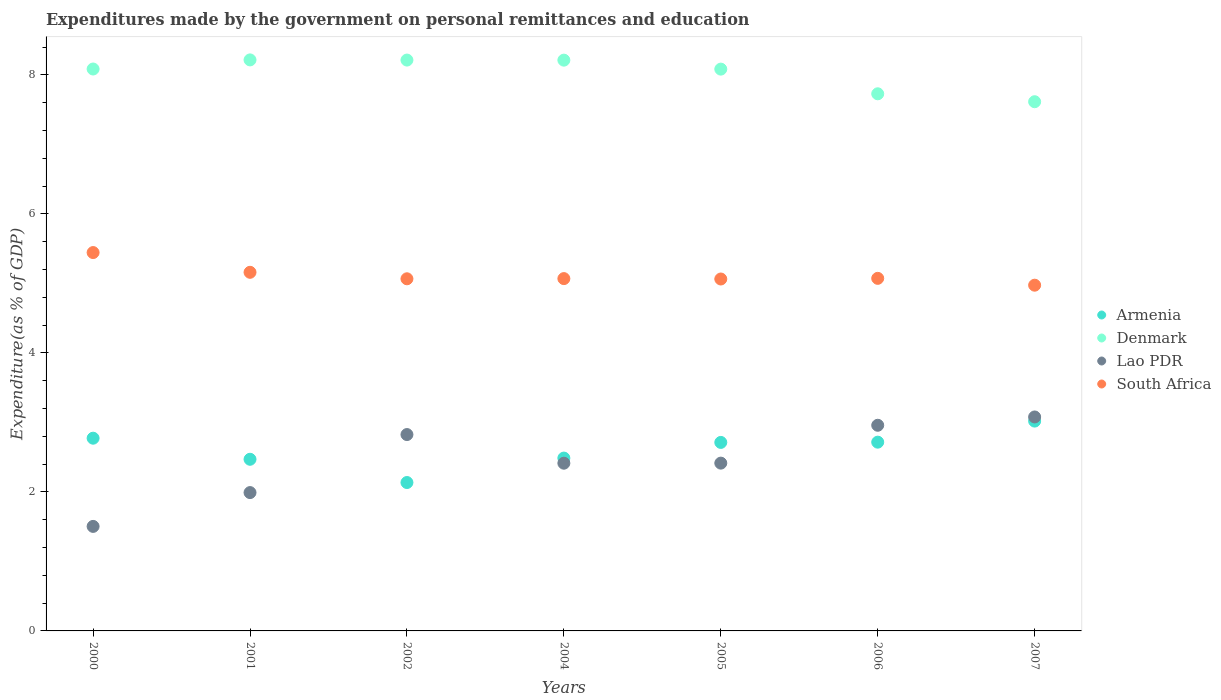How many different coloured dotlines are there?
Keep it short and to the point. 4. What is the expenditures made by the government on personal remittances and education in South Africa in 2007?
Your response must be concise. 4.97. Across all years, what is the maximum expenditures made by the government on personal remittances and education in Lao PDR?
Keep it short and to the point. 3.08. Across all years, what is the minimum expenditures made by the government on personal remittances and education in South Africa?
Your response must be concise. 4.97. In which year was the expenditures made by the government on personal remittances and education in Lao PDR maximum?
Offer a terse response. 2007. In which year was the expenditures made by the government on personal remittances and education in Denmark minimum?
Ensure brevity in your answer.  2007. What is the total expenditures made by the government on personal remittances and education in Denmark in the graph?
Offer a terse response. 56.15. What is the difference between the expenditures made by the government on personal remittances and education in Armenia in 2001 and that in 2004?
Keep it short and to the point. -0.02. What is the difference between the expenditures made by the government on personal remittances and education in Lao PDR in 2006 and the expenditures made by the government on personal remittances and education in Denmark in 2004?
Provide a short and direct response. -5.25. What is the average expenditures made by the government on personal remittances and education in Lao PDR per year?
Give a very brief answer. 2.45. In the year 2005, what is the difference between the expenditures made by the government on personal remittances and education in South Africa and expenditures made by the government on personal remittances and education in Denmark?
Offer a very short reply. -3.02. In how many years, is the expenditures made by the government on personal remittances and education in Lao PDR greater than 0.8 %?
Your answer should be compact. 7. What is the ratio of the expenditures made by the government on personal remittances and education in Denmark in 2001 to that in 2002?
Offer a terse response. 1. Is the expenditures made by the government on personal remittances and education in Armenia in 2005 less than that in 2006?
Make the answer very short. Yes. What is the difference between the highest and the second highest expenditures made by the government on personal remittances and education in Lao PDR?
Offer a very short reply. 0.12. What is the difference between the highest and the lowest expenditures made by the government on personal remittances and education in Denmark?
Your answer should be very brief. 0.6. In how many years, is the expenditures made by the government on personal remittances and education in Denmark greater than the average expenditures made by the government on personal remittances and education in Denmark taken over all years?
Provide a succinct answer. 5. Is it the case that in every year, the sum of the expenditures made by the government on personal remittances and education in Denmark and expenditures made by the government on personal remittances and education in Armenia  is greater than the expenditures made by the government on personal remittances and education in South Africa?
Ensure brevity in your answer.  Yes. Does the expenditures made by the government on personal remittances and education in Lao PDR monotonically increase over the years?
Your response must be concise. No. Is the expenditures made by the government on personal remittances and education in Armenia strictly less than the expenditures made by the government on personal remittances and education in Lao PDR over the years?
Your answer should be very brief. No. How many years are there in the graph?
Keep it short and to the point. 7. What is the difference between two consecutive major ticks on the Y-axis?
Ensure brevity in your answer.  2. How many legend labels are there?
Provide a succinct answer. 4. What is the title of the graph?
Provide a short and direct response. Expenditures made by the government on personal remittances and education. Does "St. Martin (French part)" appear as one of the legend labels in the graph?
Provide a succinct answer. No. What is the label or title of the X-axis?
Offer a terse response. Years. What is the label or title of the Y-axis?
Provide a succinct answer. Expenditure(as % of GDP). What is the Expenditure(as % of GDP) of Armenia in 2000?
Ensure brevity in your answer.  2.77. What is the Expenditure(as % of GDP) of Denmark in 2000?
Keep it short and to the point. 8.08. What is the Expenditure(as % of GDP) in Lao PDR in 2000?
Your response must be concise. 1.5. What is the Expenditure(as % of GDP) in South Africa in 2000?
Make the answer very short. 5.44. What is the Expenditure(as % of GDP) of Armenia in 2001?
Your answer should be compact. 2.47. What is the Expenditure(as % of GDP) in Denmark in 2001?
Your answer should be very brief. 8.22. What is the Expenditure(as % of GDP) of Lao PDR in 2001?
Keep it short and to the point. 1.99. What is the Expenditure(as % of GDP) in South Africa in 2001?
Your answer should be very brief. 5.16. What is the Expenditure(as % of GDP) in Armenia in 2002?
Ensure brevity in your answer.  2.14. What is the Expenditure(as % of GDP) of Denmark in 2002?
Provide a succinct answer. 8.21. What is the Expenditure(as % of GDP) in Lao PDR in 2002?
Offer a very short reply. 2.83. What is the Expenditure(as % of GDP) of South Africa in 2002?
Make the answer very short. 5.07. What is the Expenditure(as % of GDP) in Armenia in 2004?
Ensure brevity in your answer.  2.49. What is the Expenditure(as % of GDP) in Denmark in 2004?
Make the answer very short. 8.21. What is the Expenditure(as % of GDP) in Lao PDR in 2004?
Your response must be concise. 2.41. What is the Expenditure(as % of GDP) in South Africa in 2004?
Make the answer very short. 5.07. What is the Expenditure(as % of GDP) of Armenia in 2005?
Your answer should be compact. 2.71. What is the Expenditure(as % of GDP) of Denmark in 2005?
Offer a terse response. 8.08. What is the Expenditure(as % of GDP) of Lao PDR in 2005?
Your answer should be compact. 2.41. What is the Expenditure(as % of GDP) in South Africa in 2005?
Give a very brief answer. 5.06. What is the Expenditure(as % of GDP) of Armenia in 2006?
Keep it short and to the point. 2.72. What is the Expenditure(as % of GDP) of Denmark in 2006?
Your answer should be very brief. 7.73. What is the Expenditure(as % of GDP) of Lao PDR in 2006?
Your answer should be compact. 2.96. What is the Expenditure(as % of GDP) in South Africa in 2006?
Your response must be concise. 5.07. What is the Expenditure(as % of GDP) of Armenia in 2007?
Make the answer very short. 3.02. What is the Expenditure(as % of GDP) in Denmark in 2007?
Provide a short and direct response. 7.61. What is the Expenditure(as % of GDP) in Lao PDR in 2007?
Provide a succinct answer. 3.08. What is the Expenditure(as % of GDP) in South Africa in 2007?
Your response must be concise. 4.97. Across all years, what is the maximum Expenditure(as % of GDP) of Armenia?
Ensure brevity in your answer.  3.02. Across all years, what is the maximum Expenditure(as % of GDP) of Denmark?
Keep it short and to the point. 8.22. Across all years, what is the maximum Expenditure(as % of GDP) of Lao PDR?
Give a very brief answer. 3.08. Across all years, what is the maximum Expenditure(as % of GDP) in South Africa?
Your answer should be compact. 5.44. Across all years, what is the minimum Expenditure(as % of GDP) of Armenia?
Your answer should be compact. 2.14. Across all years, what is the minimum Expenditure(as % of GDP) in Denmark?
Make the answer very short. 7.61. Across all years, what is the minimum Expenditure(as % of GDP) of Lao PDR?
Give a very brief answer. 1.5. Across all years, what is the minimum Expenditure(as % of GDP) in South Africa?
Your response must be concise. 4.97. What is the total Expenditure(as % of GDP) of Armenia in the graph?
Your answer should be compact. 18.31. What is the total Expenditure(as % of GDP) in Denmark in the graph?
Ensure brevity in your answer.  56.15. What is the total Expenditure(as % of GDP) in Lao PDR in the graph?
Provide a succinct answer. 17.18. What is the total Expenditure(as % of GDP) in South Africa in the graph?
Your answer should be very brief. 35.85. What is the difference between the Expenditure(as % of GDP) in Armenia in 2000 and that in 2001?
Provide a succinct answer. 0.3. What is the difference between the Expenditure(as % of GDP) of Denmark in 2000 and that in 2001?
Provide a succinct answer. -0.13. What is the difference between the Expenditure(as % of GDP) of Lao PDR in 2000 and that in 2001?
Make the answer very short. -0.49. What is the difference between the Expenditure(as % of GDP) of South Africa in 2000 and that in 2001?
Keep it short and to the point. 0.28. What is the difference between the Expenditure(as % of GDP) of Armenia in 2000 and that in 2002?
Your answer should be very brief. 0.64. What is the difference between the Expenditure(as % of GDP) of Denmark in 2000 and that in 2002?
Provide a short and direct response. -0.13. What is the difference between the Expenditure(as % of GDP) of Lao PDR in 2000 and that in 2002?
Give a very brief answer. -1.32. What is the difference between the Expenditure(as % of GDP) in South Africa in 2000 and that in 2002?
Offer a very short reply. 0.38. What is the difference between the Expenditure(as % of GDP) in Armenia in 2000 and that in 2004?
Keep it short and to the point. 0.29. What is the difference between the Expenditure(as % of GDP) of Denmark in 2000 and that in 2004?
Keep it short and to the point. -0.13. What is the difference between the Expenditure(as % of GDP) in Lao PDR in 2000 and that in 2004?
Make the answer very short. -0.91. What is the difference between the Expenditure(as % of GDP) in South Africa in 2000 and that in 2004?
Offer a very short reply. 0.37. What is the difference between the Expenditure(as % of GDP) in Armenia in 2000 and that in 2005?
Give a very brief answer. 0.06. What is the difference between the Expenditure(as % of GDP) in Denmark in 2000 and that in 2005?
Give a very brief answer. 0. What is the difference between the Expenditure(as % of GDP) in Lao PDR in 2000 and that in 2005?
Provide a succinct answer. -0.91. What is the difference between the Expenditure(as % of GDP) of South Africa in 2000 and that in 2005?
Give a very brief answer. 0.38. What is the difference between the Expenditure(as % of GDP) of Armenia in 2000 and that in 2006?
Make the answer very short. 0.06. What is the difference between the Expenditure(as % of GDP) in Denmark in 2000 and that in 2006?
Your answer should be very brief. 0.36. What is the difference between the Expenditure(as % of GDP) of Lao PDR in 2000 and that in 2006?
Offer a terse response. -1.46. What is the difference between the Expenditure(as % of GDP) of South Africa in 2000 and that in 2006?
Make the answer very short. 0.37. What is the difference between the Expenditure(as % of GDP) in Armenia in 2000 and that in 2007?
Provide a succinct answer. -0.25. What is the difference between the Expenditure(as % of GDP) of Denmark in 2000 and that in 2007?
Provide a short and direct response. 0.47. What is the difference between the Expenditure(as % of GDP) in Lao PDR in 2000 and that in 2007?
Your response must be concise. -1.57. What is the difference between the Expenditure(as % of GDP) of South Africa in 2000 and that in 2007?
Offer a terse response. 0.47. What is the difference between the Expenditure(as % of GDP) in Armenia in 2001 and that in 2002?
Make the answer very short. 0.33. What is the difference between the Expenditure(as % of GDP) of Denmark in 2001 and that in 2002?
Provide a short and direct response. 0. What is the difference between the Expenditure(as % of GDP) of Lao PDR in 2001 and that in 2002?
Keep it short and to the point. -0.83. What is the difference between the Expenditure(as % of GDP) in South Africa in 2001 and that in 2002?
Your answer should be compact. 0.09. What is the difference between the Expenditure(as % of GDP) of Armenia in 2001 and that in 2004?
Offer a terse response. -0.02. What is the difference between the Expenditure(as % of GDP) in Denmark in 2001 and that in 2004?
Give a very brief answer. 0. What is the difference between the Expenditure(as % of GDP) in Lao PDR in 2001 and that in 2004?
Your answer should be very brief. -0.42. What is the difference between the Expenditure(as % of GDP) of South Africa in 2001 and that in 2004?
Make the answer very short. 0.09. What is the difference between the Expenditure(as % of GDP) in Armenia in 2001 and that in 2005?
Keep it short and to the point. -0.24. What is the difference between the Expenditure(as % of GDP) in Denmark in 2001 and that in 2005?
Offer a terse response. 0.13. What is the difference between the Expenditure(as % of GDP) in Lao PDR in 2001 and that in 2005?
Offer a very short reply. -0.42. What is the difference between the Expenditure(as % of GDP) in South Africa in 2001 and that in 2005?
Your response must be concise. 0.1. What is the difference between the Expenditure(as % of GDP) in Armenia in 2001 and that in 2006?
Your answer should be compact. -0.25. What is the difference between the Expenditure(as % of GDP) in Denmark in 2001 and that in 2006?
Offer a terse response. 0.49. What is the difference between the Expenditure(as % of GDP) in Lao PDR in 2001 and that in 2006?
Give a very brief answer. -0.97. What is the difference between the Expenditure(as % of GDP) of South Africa in 2001 and that in 2006?
Make the answer very short. 0.09. What is the difference between the Expenditure(as % of GDP) of Armenia in 2001 and that in 2007?
Your answer should be very brief. -0.55. What is the difference between the Expenditure(as % of GDP) in Denmark in 2001 and that in 2007?
Keep it short and to the point. 0.6. What is the difference between the Expenditure(as % of GDP) in Lao PDR in 2001 and that in 2007?
Provide a short and direct response. -1.09. What is the difference between the Expenditure(as % of GDP) in South Africa in 2001 and that in 2007?
Your answer should be compact. 0.19. What is the difference between the Expenditure(as % of GDP) in Armenia in 2002 and that in 2004?
Offer a very short reply. -0.35. What is the difference between the Expenditure(as % of GDP) of Denmark in 2002 and that in 2004?
Your answer should be very brief. 0. What is the difference between the Expenditure(as % of GDP) of Lao PDR in 2002 and that in 2004?
Ensure brevity in your answer.  0.41. What is the difference between the Expenditure(as % of GDP) of South Africa in 2002 and that in 2004?
Provide a short and direct response. -0. What is the difference between the Expenditure(as % of GDP) in Armenia in 2002 and that in 2005?
Your response must be concise. -0.58. What is the difference between the Expenditure(as % of GDP) in Denmark in 2002 and that in 2005?
Your response must be concise. 0.13. What is the difference between the Expenditure(as % of GDP) in Lao PDR in 2002 and that in 2005?
Keep it short and to the point. 0.41. What is the difference between the Expenditure(as % of GDP) of South Africa in 2002 and that in 2005?
Offer a terse response. 0. What is the difference between the Expenditure(as % of GDP) in Armenia in 2002 and that in 2006?
Your answer should be compact. -0.58. What is the difference between the Expenditure(as % of GDP) in Denmark in 2002 and that in 2006?
Offer a very short reply. 0.49. What is the difference between the Expenditure(as % of GDP) of Lao PDR in 2002 and that in 2006?
Offer a terse response. -0.13. What is the difference between the Expenditure(as % of GDP) of South Africa in 2002 and that in 2006?
Your response must be concise. -0.01. What is the difference between the Expenditure(as % of GDP) in Armenia in 2002 and that in 2007?
Ensure brevity in your answer.  -0.88. What is the difference between the Expenditure(as % of GDP) in Denmark in 2002 and that in 2007?
Give a very brief answer. 0.6. What is the difference between the Expenditure(as % of GDP) of Lao PDR in 2002 and that in 2007?
Make the answer very short. -0.25. What is the difference between the Expenditure(as % of GDP) in South Africa in 2002 and that in 2007?
Ensure brevity in your answer.  0.09. What is the difference between the Expenditure(as % of GDP) in Armenia in 2004 and that in 2005?
Provide a short and direct response. -0.23. What is the difference between the Expenditure(as % of GDP) of Denmark in 2004 and that in 2005?
Keep it short and to the point. 0.13. What is the difference between the Expenditure(as % of GDP) of Lao PDR in 2004 and that in 2005?
Your answer should be very brief. -0. What is the difference between the Expenditure(as % of GDP) of South Africa in 2004 and that in 2005?
Keep it short and to the point. 0.01. What is the difference between the Expenditure(as % of GDP) in Armenia in 2004 and that in 2006?
Provide a succinct answer. -0.23. What is the difference between the Expenditure(as % of GDP) of Denmark in 2004 and that in 2006?
Give a very brief answer. 0.48. What is the difference between the Expenditure(as % of GDP) of Lao PDR in 2004 and that in 2006?
Keep it short and to the point. -0.55. What is the difference between the Expenditure(as % of GDP) of South Africa in 2004 and that in 2006?
Give a very brief answer. -0. What is the difference between the Expenditure(as % of GDP) in Armenia in 2004 and that in 2007?
Offer a very short reply. -0.53. What is the difference between the Expenditure(as % of GDP) of Denmark in 2004 and that in 2007?
Make the answer very short. 0.6. What is the difference between the Expenditure(as % of GDP) in Lao PDR in 2004 and that in 2007?
Make the answer very short. -0.67. What is the difference between the Expenditure(as % of GDP) of South Africa in 2004 and that in 2007?
Make the answer very short. 0.09. What is the difference between the Expenditure(as % of GDP) in Armenia in 2005 and that in 2006?
Keep it short and to the point. -0. What is the difference between the Expenditure(as % of GDP) in Denmark in 2005 and that in 2006?
Make the answer very short. 0.35. What is the difference between the Expenditure(as % of GDP) of Lao PDR in 2005 and that in 2006?
Keep it short and to the point. -0.54. What is the difference between the Expenditure(as % of GDP) in South Africa in 2005 and that in 2006?
Your answer should be very brief. -0.01. What is the difference between the Expenditure(as % of GDP) of Armenia in 2005 and that in 2007?
Your response must be concise. -0.31. What is the difference between the Expenditure(as % of GDP) in Denmark in 2005 and that in 2007?
Provide a short and direct response. 0.47. What is the difference between the Expenditure(as % of GDP) of Lao PDR in 2005 and that in 2007?
Your answer should be compact. -0.66. What is the difference between the Expenditure(as % of GDP) of South Africa in 2005 and that in 2007?
Give a very brief answer. 0.09. What is the difference between the Expenditure(as % of GDP) of Armenia in 2006 and that in 2007?
Give a very brief answer. -0.3. What is the difference between the Expenditure(as % of GDP) of Denmark in 2006 and that in 2007?
Your answer should be very brief. 0.11. What is the difference between the Expenditure(as % of GDP) of Lao PDR in 2006 and that in 2007?
Keep it short and to the point. -0.12. What is the difference between the Expenditure(as % of GDP) in South Africa in 2006 and that in 2007?
Ensure brevity in your answer.  0.1. What is the difference between the Expenditure(as % of GDP) in Armenia in 2000 and the Expenditure(as % of GDP) in Denmark in 2001?
Provide a short and direct response. -5.44. What is the difference between the Expenditure(as % of GDP) in Armenia in 2000 and the Expenditure(as % of GDP) in Lao PDR in 2001?
Your answer should be compact. 0.78. What is the difference between the Expenditure(as % of GDP) in Armenia in 2000 and the Expenditure(as % of GDP) in South Africa in 2001?
Make the answer very short. -2.39. What is the difference between the Expenditure(as % of GDP) in Denmark in 2000 and the Expenditure(as % of GDP) in Lao PDR in 2001?
Your response must be concise. 6.09. What is the difference between the Expenditure(as % of GDP) of Denmark in 2000 and the Expenditure(as % of GDP) of South Africa in 2001?
Keep it short and to the point. 2.92. What is the difference between the Expenditure(as % of GDP) in Lao PDR in 2000 and the Expenditure(as % of GDP) in South Africa in 2001?
Your answer should be very brief. -3.66. What is the difference between the Expenditure(as % of GDP) of Armenia in 2000 and the Expenditure(as % of GDP) of Denmark in 2002?
Your response must be concise. -5.44. What is the difference between the Expenditure(as % of GDP) of Armenia in 2000 and the Expenditure(as % of GDP) of Lao PDR in 2002?
Your answer should be compact. -0.05. What is the difference between the Expenditure(as % of GDP) in Armenia in 2000 and the Expenditure(as % of GDP) in South Africa in 2002?
Keep it short and to the point. -2.29. What is the difference between the Expenditure(as % of GDP) of Denmark in 2000 and the Expenditure(as % of GDP) of Lao PDR in 2002?
Your answer should be very brief. 5.26. What is the difference between the Expenditure(as % of GDP) of Denmark in 2000 and the Expenditure(as % of GDP) of South Africa in 2002?
Provide a short and direct response. 3.02. What is the difference between the Expenditure(as % of GDP) of Lao PDR in 2000 and the Expenditure(as % of GDP) of South Africa in 2002?
Ensure brevity in your answer.  -3.56. What is the difference between the Expenditure(as % of GDP) of Armenia in 2000 and the Expenditure(as % of GDP) of Denmark in 2004?
Make the answer very short. -5.44. What is the difference between the Expenditure(as % of GDP) in Armenia in 2000 and the Expenditure(as % of GDP) in Lao PDR in 2004?
Provide a succinct answer. 0.36. What is the difference between the Expenditure(as % of GDP) of Armenia in 2000 and the Expenditure(as % of GDP) of South Africa in 2004?
Your answer should be compact. -2.3. What is the difference between the Expenditure(as % of GDP) in Denmark in 2000 and the Expenditure(as % of GDP) in Lao PDR in 2004?
Your answer should be very brief. 5.67. What is the difference between the Expenditure(as % of GDP) in Denmark in 2000 and the Expenditure(as % of GDP) in South Africa in 2004?
Make the answer very short. 3.02. What is the difference between the Expenditure(as % of GDP) in Lao PDR in 2000 and the Expenditure(as % of GDP) in South Africa in 2004?
Provide a succinct answer. -3.57. What is the difference between the Expenditure(as % of GDP) of Armenia in 2000 and the Expenditure(as % of GDP) of Denmark in 2005?
Keep it short and to the point. -5.31. What is the difference between the Expenditure(as % of GDP) of Armenia in 2000 and the Expenditure(as % of GDP) of Lao PDR in 2005?
Give a very brief answer. 0.36. What is the difference between the Expenditure(as % of GDP) of Armenia in 2000 and the Expenditure(as % of GDP) of South Africa in 2005?
Ensure brevity in your answer.  -2.29. What is the difference between the Expenditure(as % of GDP) in Denmark in 2000 and the Expenditure(as % of GDP) in Lao PDR in 2005?
Provide a short and direct response. 5.67. What is the difference between the Expenditure(as % of GDP) of Denmark in 2000 and the Expenditure(as % of GDP) of South Africa in 2005?
Your answer should be very brief. 3.02. What is the difference between the Expenditure(as % of GDP) of Lao PDR in 2000 and the Expenditure(as % of GDP) of South Africa in 2005?
Provide a succinct answer. -3.56. What is the difference between the Expenditure(as % of GDP) in Armenia in 2000 and the Expenditure(as % of GDP) in Denmark in 2006?
Give a very brief answer. -4.96. What is the difference between the Expenditure(as % of GDP) of Armenia in 2000 and the Expenditure(as % of GDP) of Lao PDR in 2006?
Provide a short and direct response. -0.19. What is the difference between the Expenditure(as % of GDP) in Armenia in 2000 and the Expenditure(as % of GDP) in South Africa in 2006?
Your answer should be very brief. -2.3. What is the difference between the Expenditure(as % of GDP) of Denmark in 2000 and the Expenditure(as % of GDP) of Lao PDR in 2006?
Offer a very short reply. 5.13. What is the difference between the Expenditure(as % of GDP) in Denmark in 2000 and the Expenditure(as % of GDP) in South Africa in 2006?
Ensure brevity in your answer.  3.01. What is the difference between the Expenditure(as % of GDP) in Lao PDR in 2000 and the Expenditure(as % of GDP) in South Africa in 2006?
Your answer should be very brief. -3.57. What is the difference between the Expenditure(as % of GDP) of Armenia in 2000 and the Expenditure(as % of GDP) of Denmark in 2007?
Your response must be concise. -4.84. What is the difference between the Expenditure(as % of GDP) of Armenia in 2000 and the Expenditure(as % of GDP) of Lao PDR in 2007?
Your answer should be very brief. -0.31. What is the difference between the Expenditure(as % of GDP) of Armenia in 2000 and the Expenditure(as % of GDP) of South Africa in 2007?
Make the answer very short. -2.2. What is the difference between the Expenditure(as % of GDP) in Denmark in 2000 and the Expenditure(as % of GDP) in Lao PDR in 2007?
Ensure brevity in your answer.  5.01. What is the difference between the Expenditure(as % of GDP) of Denmark in 2000 and the Expenditure(as % of GDP) of South Africa in 2007?
Ensure brevity in your answer.  3.11. What is the difference between the Expenditure(as % of GDP) in Lao PDR in 2000 and the Expenditure(as % of GDP) in South Africa in 2007?
Make the answer very short. -3.47. What is the difference between the Expenditure(as % of GDP) in Armenia in 2001 and the Expenditure(as % of GDP) in Denmark in 2002?
Give a very brief answer. -5.74. What is the difference between the Expenditure(as % of GDP) of Armenia in 2001 and the Expenditure(as % of GDP) of Lao PDR in 2002?
Keep it short and to the point. -0.36. What is the difference between the Expenditure(as % of GDP) in Armenia in 2001 and the Expenditure(as % of GDP) in South Africa in 2002?
Offer a terse response. -2.6. What is the difference between the Expenditure(as % of GDP) in Denmark in 2001 and the Expenditure(as % of GDP) in Lao PDR in 2002?
Give a very brief answer. 5.39. What is the difference between the Expenditure(as % of GDP) of Denmark in 2001 and the Expenditure(as % of GDP) of South Africa in 2002?
Offer a terse response. 3.15. What is the difference between the Expenditure(as % of GDP) of Lao PDR in 2001 and the Expenditure(as % of GDP) of South Africa in 2002?
Your response must be concise. -3.08. What is the difference between the Expenditure(as % of GDP) of Armenia in 2001 and the Expenditure(as % of GDP) of Denmark in 2004?
Offer a terse response. -5.74. What is the difference between the Expenditure(as % of GDP) in Armenia in 2001 and the Expenditure(as % of GDP) in Lao PDR in 2004?
Offer a very short reply. 0.06. What is the difference between the Expenditure(as % of GDP) of Armenia in 2001 and the Expenditure(as % of GDP) of South Africa in 2004?
Provide a short and direct response. -2.6. What is the difference between the Expenditure(as % of GDP) of Denmark in 2001 and the Expenditure(as % of GDP) of Lao PDR in 2004?
Your answer should be very brief. 5.8. What is the difference between the Expenditure(as % of GDP) of Denmark in 2001 and the Expenditure(as % of GDP) of South Africa in 2004?
Your response must be concise. 3.15. What is the difference between the Expenditure(as % of GDP) in Lao PDR in 2001 and the Expenditure(as % of GDP) in South Africa in 2004?
Keep it short and to the point. -3.08. What is the difference between the Expenditure(as % of GDP) in Armenia in 2001 and the Expenditure(as % of GDP) in Denmark in 2005?
Give a very brief answer. -5.61. What is the difference between the Expenditure(as % of GDP) of Armenia in 2001 and the Expenditure(as % of GDP) of Lao PDR in 2005?
Give a very brief answer. 0.06. What is the difference between the Expenditure(as % of GDP) in Armenia in 2001 and the Expenditure(as % of GDP) in South Africa in 2005?
Offer a terse response. -2.59. What is the difference between the Expenditure(as % of GDP) in Denmark in 2001 and the Expenditure(as % of GDP) in Lao PDR in 2005?
Offer a very short reply. 5.8. What is the difference between the Expenditure(as % of GDP) in Denmark in 2001 and the Expenditure(as % of GDP) in South Africa in 2005?
Provide a succinct answer. 3.15. What is the difference between the Expenditure(as % of GDP) in Lao PDR in 2001 and the Expenditure(as % of GDP) in South Africa in 2005?
Offer a very short reply. -3.07. What is the difference between the Expenditure(as % of GDP) of Armenia in 2001 and the Expenditure(as % of GDP) of Denmark in 2006?
Make the answer very short. -5.26. What is the difference between the Expenditure(as % of GDP) of Armenia in 2001 and the Expenditure(as % of GDP) of Lao PDR in 2006?
Give a very brief answer. -0.49. What is the difference between the Expenditure(as % of GDP) of Armenia in 2001 and the Expenditure(as % of GDP) of South Africa in 2006?
Provide a succinct answer. -2.6. What is the difference between the Expenditure(as % of GDP) in Denmark in 2001 and the Expenditure(as % of GDP) in Lao PDR in 2006?
Provide a succinct answer. 5.26. What is the difference between the Expenditure(as % of GDP) in Denmark in 2001 and the Expenditure(as % of GDP) in South Africa in 2006?
Your answer should be very brief. 3.14. What is the difference between the Expenditure(as % of GDP) in Lao PDR in 2001 and the Expenditure(as % of GDP) in South Africa in 2006?
Keep it short and to the point. -3.08. What is the difference between the Expenditure(as % of GDP) in Armenia in 2001 and the Expenditure(as % of GDP) in Denmark in 2007?
Your answer should be compact. -5.14. What is the difference between the Expenditure(as % of GDP) in Armenia in 2001 and the Expenditure(as % of GDP) in Lao PDR in 2007?
Keep it short and to the point. -0.61. What is the difference between the Expenditure(as % of GDP) in Armenia in 2001 and the Expenditure(as % of GDP) in South Africa in 2007?
Your answer should be compact. -2.5. What is the difference between the Expenditure(as % of GDP) of Denmark in 2001 and the Expenditure(as % of GDP) of Lao PDR in 2007?
Offer a terse response. 5.14. What is the difference between the Expenditure(as % of GDP) of Denmark in 2001 and the Expenditure(as % of GDP) of South Africa in 2007?
Your response must be concise. 3.24. What is the difference between the Expenditure(as % of GDP) in Lao PDR in 2001 and the Expenditure(as % of GDP) in South Africa in 2007?
Keep it short and to the point. -2.98. What is the difference between the Expenditure(as % of GDP) in Armenia in 2002 and the Expenditure(as % of GDP) in Denmark in 2004?
Offer a terse response. -6.08. What is the difference between the Expenditure(as % of GDP) in Armenia in 2002 and the Expenditure(as % of GDP) in Lao PDR in 2004?
Provide a succinct answer. -0.28. What is the difference between the Expenditure(as % of GDP) of Armenia in 2002 and the Expenditure(as % of GDP) of South Africa in 2004?
Make the answer very short. -2.93. What is the difference between the Expenditure(as % of GDP) of Denmark in 2002 and the Expenditure(as % of GDP) of South Africa in 2004?
Offer a very short reply. 3.14. What is the difference between the Expenditure(as % of GDP) in Lao PDR in 2002 and the Expenditure(as % of GDP) in South Africa in 2004?
Provide a short and direct response. -2.24. What is the difference between the Expenditure(as % of GDP) in Armenia in 2002 and the Expenditure(as % of GDP) in Denmark in 2005?
Make the answer very short. -5.95. What is the difference between the Expenditure(as % of GDP) of Armenia in 2002 and the Expenditure(as % of GDP) of Lao PDR in 2005?
Provide a short and direct response. -0.28. What is the difference between the Expenditure(as % of GDP) in Armenia in 2002 and the Expenditure(as % of GDP) in South Africa in 2005?
Make the answer very short. -2.93. What is the difference between the Expenditure(as % of GDP) in Denmark in 2002 and the Expenditure(as % of GDP) in Lao PDR in 2005?
Give a very brief answer. 5.8. What is the difference between the Expenditure(as % of GDP) of Denmark in 2002 and the Expenditure(as % of GDP) of South Africa in 2005?
Give a very brief answer. 3.15. What is the difference between the Expenditure(as % of GDP) of Lao PDR in 2002 and the Expenditure(as % of GDP) of South Africa in 2005?
Provide a succinct answer. -2.24. What is the difference between the Expenditure(as % of GDP) of Armenia in 2002 and the Expenditure(as % of GDP) of Denmark in 2006?
Offer a very short reply. -5.59. What is the difference between the Expenditure(as % of GDP) in Armenia in 2002 and the Expenditure(as % of GDP) in Lao PDR in 2006?
Ensure brevity in your answer.  -0.82. What is the difference between the Expenditure(as % of GDP) in Armenia in 2002 and the Expenditure(as % of GDP) in South Africa in 2006?
Offer a terse response. -2.94. What is the difference between the Expenditure(as % of GDP) of Denmark in 2002 and the Expenditure(as % of GDP) of Lao PDR in 2006?
Offer a terse response. 5.25. What is the difference between the Expenditure(as % of GDP) in Denmark in 2002 and the Expenditure(as % of GDP) in South Africa in 2006?
Your response must be concise. 3.14. What is the difference between the Expenditure(as % of GDP) in Lao PDR in 2002 and the Expenditure(as % of GDP) in South Africa in 2006?
Offer a terse response. -2.25. What is the difference between the Expenditure(as % of GDP) in Armenia in 2002 and the Expenditure(as % of GDP) in Denmark in 2007?
Make the answer very short. -5.48. What is the difference between the Expenditure(as % of GDP) of Armenia in 2002 and the Expenditure(as % of GDP) of Lao PDR in 2007?
Provide a short and direct response. -0.94. What is the difference between the Expenditure(as % of GDP) in Armenia in 2002 and the Expenditure(as % of GDP) in South Africa in 2007?
Provide a succinct answer. -2.84. What is the difference between the Expenditure(as % of GDP) of Denmark in 2002 and the Expenditure(as % of GDP) of Lao PDR in 2007?
Provide a short and direct response. 5.13. What is the difference between the Expenditure(as % of GDP) of Denmark in 2002 and the Expenditure(as % of GDP) of South Africa in 2007?
Ensure brevity in your answer.  3.24. What is the difference between the Expenditure(as % of GDP) of Lao PDR in 2002 and the Expenditure(as % of GDP) of South Africa in 2007?
Keep it short and to the point. -2.15. What is the difference between the Expenditure(as % of GDP) in Armenia in 2004 and the Expenditure(as % of GDP) in Denmark in 2005?
Give a very brief answer. -5.6. What is the difference between the Expenditure(as % of GDP) in Armenia in 2004 and the Expenditure(as % of GDP) in Lao PDR in 2005?
Offer a very short reply. 0.07. What is the difference between the Expenditure(as % of GDP) of Armenia in 2004 and the Expenditure(as % of GDP) of South Africa in 2005?
Your answer should be very brief. -2.58. What is the difference between the Expenditure(as % of GDP) in Denmark in 2004 and the Expenditure(as % of GDP) in Lao PDR in 2005?
Provide a succinct answer. 5.8. What is the difference between the Expenditure(as % of GDP) in Denmark in 2004 and the Expenditure(as % of GDP) in South Africa in 2005?
Your answer should be very brief. 3.15. What is the difference between the Expenditure(as % of GDP) of Lao PDR in 2004 and the Expenditure(as % of GDP) of South Africa in 2005?
Offer a terse response. -2.65. What is the difference between the Expenditure(as % of GDP) of Armenia in 2004 and the Expenditure(as % of GDP) of Denmark in 2006?
Offer a terse response. -5.24. What is the difference between the Expenditure(as % of GDP) in Armenia in 2004 and the Expenditure(as % of GDP) in Lao PDR in 2006?
Your answer should be very brief. -0.47. What is the difference between the Expenditure(as % of GDP) in Armenia in 2004 and the Expenditure(as % of GDP) in South Africa in 2006?
Your answer should be compact. -2.59. What is the difference between the Expenditure(as % of GDP) of Denmark in 2004 and the Expenditure(as % of GDP) of Lao PDR in 2006?
Give a very brief answer. 5.25. What is the difference between the Expenditure(as % of GDP) of Denmark in 2004 and the Expenditure(as % of GDP) of South Africa in 2006?
Keep it short and to the point. 3.14. What is the difference between the Expenditure(as % of GDP) of Lao PDR in 2004 and the Expenditure(as % of GDP) of South Africa in 2006?
Keep it short and to the point. -2.66. What is the difference between the Expenditure(as % of GDP) of Armenia in 2004 and the Expenditure(as % of GDP) of Denmark in 2007?
Give a very brief answer. -5.13. What is the difference between the Expenditure(as % of GDP) of Armenia in 2004 and the Expenditure(as % of GDP) of Lao PDR in 2007?
Ensure brevity in your answer.  -0.59. What is the difference between the Expenditure(as % of GDP) of Armenia in 2004 and the Expenditure(as % of GDP) of South Africa in 2007?
Provide a succinct answer. -2.49. What is the difference between the Expenditure(as % of GDP) in Denmark in 2004 and the Expenditure(as % of GDP) in Lao PDR in 2007?
Provide a short and direct response. 5.13. What is the difference between the Expenditure(as % of GDP) in Denmark in 2004 and the Expenditure(as % of GDP) in South Africa in 2007?
Provide a succinct answer. 3.24. What is the difference between the Expenditure(as % of GDP) of Lao PDR in 2004 and the Expenditure(as % of GDP) of South Africa in 2007?
Give a very brief answer. -2.56. What is the difference between the Expenditure(as % of GDP) of Armenia in 2005 and the Expenditure(as % of GDP) of Denmark in 2006?
Ensure brevity in your answer.  -5.02. What is the difference between the Expenditure(as % of GDP) of Armenia in 2005 and the Expenditure(as % of GDP) of Lao PDR in 2006?
Offer a very short reply. -0.25. What is the difference between the Expenditure(as % of GDP) of Armenia in 2005 and the Expenditure(as % of GDP) of South Africa in 2006?
Keep it short and to the point. -2.36. What is the difference between the Expenditure(as % of GDP) of Denmark in 2005 and the Expenditure(as % of GDP) of Lao PDR in 2006?
Give a very brief answer. 5.12. What is the difference between the Expenditure(as % of GDP) of Denmark in 2005 and the Expenditure(as % of GDP) of South Africa in 2006?
Provide a succinct answer. 3.01. What is the difference between the Expenditure(as % of GDP) of Lao PDR in 2005 and the Expenditure(as % of GDP) of South Africa in 2006?
Offer a very short reply. -2.66. What is the difference between the Expenditure(as % of GDP) of Armenia in 2005 and the Expenditure(as % of GDP) of Denmark in 2007?
Ensure brevity in your answer.  -4.9. What is the difference between the Expenditure(as % of GDP) of Armenia in 2005 and the Expenditure(as % of GDP) of Lao PDR in 2007?
Ensure brevity in your answer.  -0.37. What is the difference between the Expenditure(as % of GDP) of Armenia in 2005 and the Expenditure(as % of GDP) of South Africa in 2007?
Offer a very short reply. -2.26. What is the difference between the Expenditure(as % of GDP) in Denmark in 2005 and the Expenditure(as % of GDP) in Lao PDR in 2007?
Make the answer very short. 5. What is the difference between the Expenditure(as % of GDP) in Denmark in 2005 and the Expenditure(as % of GDP) in South Africa in 2007?
Your response must be concise. 3.11. What is the difference between the Expenditure(as % of GDP) in Lao PDR in 2005 and the Expenditure(as % of GDP) in South Africa in 2007?
Provide a short and direct response. -2.56. What is the difference between the Expenditure(as % of GDP) in Armenia in 2006 and the Expenditure(as % of GDP) in Denmark in 2007?
Your response must be concise. -4.9. What is the difference between the Expenditure(as % of GDP) of Armenia in 2006 and the Expenditure(as % of GDP) of Lao PDR in 2007?
Provide a succinct answer. -0.36. What is the difference between the Expenditure(as % of GDP) in Armenia in 2006 and the Expenditure(as % of GDP) in South Africa in 2007?
Offer a terse response. -2.26. What is the difference between the Expenditure(as % of GDP) in Denmark in 2006 and the Expenditure(as % of GDP) in Lao PDR in 2007?
Keep it short and to the point. 4.65. What is the difference between the Expenditure(as % of GDP) in Denmark in 2006 and the Expenditure(as % of GDP) in South Africa in 2007?
Your answer should be very brief. 2.75. What is the difference between the Expenditure(as % of GDP) of Lao PDR in 2006 and the Expenditure(as % of GDP) of South Africa in 2007?
Provide a short and direct response. -2.02. What is the average Expenditure(as % of GDP) of Armenia per year?
Keep it short and to the point. 2.62. What is the average Expenditure(as % of GDP) of Denmark per year?
Give a very brief answer. 8.02. What is the average Expenditure(as % of GDP) of Lao PDR per year?
Provide a short and direct response. 2.45. What is the average Expenditure(as % of GDP) of South Africa per year?
Your answer should be compact. 5.12. In the year 2000, what is the difference between the Expenditure(as % of GDP) in Armenia and Expenditure(as % of GDP) in Denmark?
Provide a short and direct response. -5.31. In the year 2000, what is the difference between the Expenditure(as % of GDP) of Armenia and Expenditure(as % of GDP) of Lao PDR?
Make the answer very short. 1.27. In the year 2000, what is the difference between the Expenditure(as % of GDP) of Armenia and Expenditure(as % of GDP) of South Africa?
Make the answer very short. -2.67. In the year 2000, what is the difference between the Expenditure(as % of GDP) in Denmark and Expenditure(as % of GDP) in Lao PDR?
Ensure brevity in your answer.  6.58. In the year 2000, what is the difference between the Expenditure(as % of GDP) of Denmark and Expenditure(as % of GDP) of South Africa?
Keep it short and to the point. 2.64. In the year 2000, what is the difference between the Expenditure(as % of GDP) of Lao PDR and Expenditure(as % of GDP) of South Africa?
Keep it short and to the point. -3.94. In the year 2001, what is the difference between the Expenditure(as % of GDP) of Armenia and Expenditure(as % of GDP) of Denmark?
Your response must be concise. -5.75. In the year 2001, what is the difference between the Expenditure(as % of GDP) in Armenia and Expenditure(as % of GDP) in Lao PDR?
Make the answer very short. 0.48. In the year 2001, what is the difference between the Expenditure(as % of GDP) in Armenia and Expenditure(as % of GDP) in South Africa?
Ensure brevity in your answer.  -2.69. In the year 2001, what is the difference between the Expenditure(as % of GDP) in Denmark and Expenditure(as % of GDP) in Lao PDR?
Ensure brevity in your answer.  6.23. In the year 2001, what is the difference between the Expenditure(as % of GDP) in Denmark and Expenditure(as % of GDP) in South Africa?
Provide a short and direct response. 3.06. In the year 2001, what is the difference between the Expenditure(as % of GDP) in Lao PDR and Expenditure(as % of GDP) in South Africa?
Give a very brief answer. -3.17. In the year 2002, what is the difference between the Expenditure(as % of GDP) in Armenia and Expenditure(as % of GDP) in Denmark?
Your answer should be compact. -6.08. In the year 2002, what is the difference between the Expenditure(as % of GDP) of Armenia and Expenditure(as % of GDP) of Lao PDR?
Give a very brief answer. -0.69. In the year 2002, what is the difference between the Expenditure(as % of GDP) in Armenia and Expenditure(as % of GDP) in South Africa?
Provide a short and direct response. -2.93. In the year 2002, what is the difference between the Expenditure(as % of GDP) of Denmark and Expenditure(as % of GDP) of Lao PDR?
Your answer should be very brief. 5.39. In the year 2002, what is the difference between the Expenditure(as % of GDP) of Denmark and Expenditure(as % of GDP) of South Africa?
Your answer should be compact. 3.15. In the year 2002, what is the difference between the Expenditure(as % of GDP) in Lao PDR and Expenditure(as % of GDP) in South Africa?
Provide a short and direct response. -2.24. In the year 2004, what is the difference between the Expenditure(as % of GDP) of Armenia and Expenditure(as % of GDP) of Denmark?
Offer a terse response. -5.73. In the year 2004, what is the difference between the Expenditure(as % of GDP) in Armenia and Expenditure(as % of GDP) in Lao PDR?
Provide a short and direct response. 0.07. In the year 2004, what is the difference between the Expenditure(as % of GDP) of Armenia and Expenditure(as % of GDP) of South Africa?
Ensure brevity in your answer.  -2.58. In the year 2004, what is the difference between the Expenditure(as % of GDP) of Denmark and Expenditure(as % of GDP) of Lao PDR?
Ensure brevity in your answer.  5.8. In the year 2004, what is the difference between the Expenditure(as % of GDP) in Denmark and Expenditure(as % of GDP) in South Africa?
Your answer should be compact. 3.14. In the year 2004, what is the difference between the Expenditure(as % of GDP) of Lao PDR and Expenditure(as % of GDP) of South Africa?
Ensure brevity in your answer.  -2.66. In the year 2005, what is the difference between the Expenditure(as % of GDP) of Armenia and Expenditure(as % of GDP) of Denmark?
Ensure brevity in your answer.  -5.37. In the year 2005, what is the difference between the Expenditure(as % of GDP) in Armenia and Expenditure(as % of GDP) in Lao PDR?
Provide a succinct answer. 0.3. In the year 2005, what is the difference between the Expenditure(as % of GDP) in Armenia and Expenditure(as % of GDP) in South Africa?
Your answer should be very brief. -2.35. In the year 2005, what is the difference between the Expenditure(as % of GDP) in Denmark and Expenditure(as % of GDP) in Lao PDR?
Provide a succinct answer. 5.67. In the year 2005, what is the difference between the Expenditure(as % of GDP) in Denmark and Expenditure(as % of GDP) in South Africa?
Provide a succinct answer. 3.02. In the year 2005, what is the difference between the Expenditure(as % of GDP) in Lao PDR and Expenditure(as % of GDP) in South Africa?
Offer a very short reply. -2.65. In the year 2006, what is the difference between the Expenditure(as % of GDP) of Armenia and Expenditure(as % of GDP) of Denmark?
Offer a very short reply. -5.01. In the year 2006, what is the difference between the Expenditure(as % of GDP) in Armenia and Expenditure(as % of GDP) in Lao PDR?
Provide a succinct answer. -0.24. In the year 2006, what is the difference between the Expenditure(as % of GDP) of Armenia and Expenditure(as % of GDP) of South Africa?
Ensure brevity in your answer.  -2.36. In the year 2006, what is the difference between the Expenditure(as % of GDP) in Denmark and Expenditure(as % of GDP) in Lao PDR?
Make the answer very short. 4.77. In the year 2006, what is the difference between the Expenditure(as % of GDP) of Denmark and Expenditure(as % of GDP) of South Africa?
Your answer should be very brief. 2.66. In the year 2006, what is the difference between the Expenditure(as % of GDP) of Lao PDR and Expenditure(as % of GDP) of South Africa?
Make the answer very short. -2.11. In the year 2007, what is the difference between the Expenditure(as % of GDP) in Armenia and Expenditure(as % of GDP) in Denmark?
Ensure brevity in your answer.  -4.59. In the year 2007, what is the difference between the Expenditure(as % of GDP) of Armenia and Expenditure(as % of GDP) of Lao PDR?
Make the answer very short. -0.06. In the year 2007, what is the difference between the Expenditure(as % of GDP) in Armenia and Expenditure(as % of GDP) in South Africa?
Provide a succinct answer. -1.96. In the year 2007, what is the difference between the Expenditure(as % of GDP) in Denmark and Expenditure(as % of GDP) in Lao PDR?
Ensure brevity in your answer.  4.54. In the year 2007, what is the difference between the Expenditure(as % of GDP) in Denmark and Expenditure(as % of GDP) in South Africa?
Your answer should be very brief. 2.64. In the year 2007, what is the difference between the Expenditure(as % of GDP) in Lao PDR and Expenditure(as % of GDP) in South Africa?
Your response must be concise. -1.9. What is the ratio of the Expenditure(as % of GDP) in Armenia in 2000 to that in 2001?
Your response must be concise. 1.12. What is the ratio of the Expenditure(as % of GDP) in Lao PDR in 2000 to that in 2001?
Your answer should be compact. 0.76. What is the ratio of the Expenditure(as % of GDP) of South Africa in 2000 to that in 2001?
Make the answer very short. 1.06. What is the ratio of the Expenditure(as % of GDP) in Armenia in 2000 to that in 2002?
Your response must be concise. 1.3. What is the ratio of the Expenditure(as % of GDP) of Denmark in 2000 to that in 2002?
Offer a very short reply. 0.98. What is the ratio of the Expenditure(as % of GDP) in Lao PDR in 2000 to that in 2002?
Make the answer very short. 0.53. What is the ratio of the Expenditure(as % of GDP) in South Africa in 2000 to that in 2002?
Your answer should be compact. 1.07. What is the ratio of the Expenditure(as % of GDP) in Armenia in 2000 to that in 2004?
Keep it short and to the point. 1.11. What is the ratio of the Expenditure(as % of GDP) of Denmark in 2000 to that in 2004?
Provide a short and direct response. 0.98. What is the ratio of the Expenditure(as % of GDP) of Lao PDR in 2000 to that in 2004?
Ensure brevity in your answer.  0.62. What is the ratio of the Expenditure(as % of GDP) of South Africa in 2000 to that in 2004?
Keep it short and to the point. 1.07. What is the ratio of the Expenditure(as % of GDP) of Armenia in 2000 to that in 2005?
Your answer should be compact. 1.02. What is the ratio of the Expenditure(as % of GDP) in Denmark in 2000 to that in 2005?
Offer a very short reply. 1. What is the ratio of the Expenditure(as % of GDP) of Lao PDR in 2000 to that in 2005?
Offer a very short reply. 0.62. What is the ratio of the Expenditure(as % of GDP) in South Africa in 2000 to that in 2005?
Give a very brief answer. 1.08. What is the ratio of the Expenditure(as % of GDP) in Armenia in 2000 to that in 2006?
Make the answer very short. 1.02. What is the ratio of the Expenditure(as % of GDP) in Denmark in 2000 to that in 2006?
Provide a succinct answer. 1.05. What is the ratio of the Expenditure(as % of GDP) of Lao PDR in 2000 to that in 2006?
Provide a short and direct response. 0.51. What is the ratio of the Expenditure(as % of GDP) in South Africa in 2000 to that in 2006?
Give a very brief answer. 1.07. What is the ratio of the Expenditure(as % of GDP) in Armenia in 2000 to that in 2007?
Offer a terse response. 0.92. What is the ratio of the Expenditure(as % of GDP) of Denmark in 2000 to that in 2007?
Make the answer very short. 1.06. What is the ratio of the Expenditure(as % of GDP) of Lao PDR in 2000 to that in 2007?
Provide a succinct answer. 0.49. What is the ratio of the Expenditure(as % of GDP) of South Africa in 2000 to that in 2007?
Make the answer very short. 1.09. What is the ratio of the Expenditure(as % of GDP) in Armenia in 2001 to that in 2002?
Ensure brevity in your answer.  1.16. What is the ratio of the Expenditure(as % of GDP) of Denmark in 2001 to that in 2002?
Your response must be concise. 1. What is the ratio of the Expenditure(as % of GDP) of Lao PDR in 2001 to that in 2002?
Provide a short and direct response. 0.7. What is the ratio of the Expenditure(as % of GDP) in South Africa in 2001 to that in 2002?
Your answer should be compact. 1.02. What is the ratio of the Expenditure(as % of GDP) in Armenia in 2001 to that in 2004?
Provide a succinct answer. 0.99. What is the ratio of the Expenditure(as % of GDP) of Lao PDR in 2001 to that in 2004?
Your response must be concise. 0.82. What is the ratio of the Expenditure(as % of GDP) in South Africa in 2001 to that in 2004?
Provide a short and direct response. 1.02. What is the ratio of the Expenditure(as % of GDP) in Armenia in 2001 to that in 2005?
Keep it short and to the point. 0.91. What is the ratio of the Expenditure(as % of GDP) in Denmark in 2001 to that in 2005?
Provide a succinct answer. 1.02. What is the ratio of the Expenditure(as % of GDP) of Lao PDR in 2001 to that in 2005?
Ensure brevity in your answer.  0.82. What is the ratio of the Expenditure(as % of GDP) in Armenia in 2001 to that in 2006?
Make the answer very short. 0.91. What is the ratio of the Expenditure(as % of GDP) in Denmark in 2001 to that in 2006?
Offer a very short reply. 1.06. What is the ratio of the Expenditure(as % of GDP) in Lao PDR in 2001 to that in 2006?
Your response must be concise. 0.67. What is the ratio of the Expenditure(as % of GDP) in South Africa in 2001 to that in 2006?
Your response must be concise. 1.02. What is the ratio of the Expenditure(as % of GDP) in Armenia in 2001 to that in 2007?
Your response must be concise. 0.82. What is the ratio of the Expenditure(as % of GDP) of Denmark in 2001 to that in 2007?
Offer a very short reply. 1.08. What is the ratio of the Expenditure(as % of GDP) in Lao PDR in 2001 to that in 2007?
Provide a succinct answer. 0.65. What is the ratio of the Expenditure(as % of GDP) in South Africa in 2001 to that in 2007?
Provide a short and direct response. 1.04. What is the ratio of the Expenditure(as % of GDP) of Armenia in 2002 to that in 2004?
Keep it short and to the point. 0.86. What is the ratio of the Expenditure(as % of GDP) in Denmark in 2002 to that in 2004?
Keep it short and to the point. 1. What is the ratio of the Expenditure(as % of GDP) in Lao PDR in 2002 to that in 2004?
Keep it short and to the point. 1.17. What is the ratio of the Expenditure(as % of GDP) in South Africa in 2002 to that in 2004?
Keep it short and to the point. 1. What is the ratio of the Expenditure(as % of GDP) in Armenia in 2002 to that in 2005?
Your answer should be compact. 0.79. What is the ratio of the Expenditure(as % of GDP) in Denmark in 2002 to that in 2005?
Give a very brief answer. 1.02. What is the ratio of the Expenditure(as % of GDP) of Lao PDR in 2002 to that in 2005?
Keep it short and to the point. 1.17. What is the ratio of the Expenditure(as % of GDP) of South Africa in 2002 to that in 2005?
Ensure brevity in your answer.  1. What is the ratio of the Expenditure(as % of GDP) in Armenia in 2002 to that in 2006?
Offer a terse response. 0.79. What is the ratio of the Expenditure(as % of GDP) of Denmark in 2002 to that in 2006?
Offer a terse response. 1.06. What is the ratio of the Expenditure(as % of GDP) of Lao PDR in 2002 to that in 2006?
Your answer should be very brief. 0.95. What is the ratio of the Expenditure(as % of GDP) of Armenia in 2002 to that in 2007?
Ensure brevity in your answer.  0.71. What is the ratio of the Expenditure(as % of GDP) in Denmark in 2002 to that in 2007?
Make the answer very short. 1.08. What is the ratio of the Expenditure(as % of GDP) in Lao PDR in 2002 to that in 2007?
Your response must be concise. 0.92. What is the ratio of the Expenditure(as % of GDP) of South Africa in 2002 to that in 2007?
Provide a short and direct response. 1.02. What is the ratio of the Expenditure(as % of GDP) in Armenia in 2004 to that in 2005?
Provide a short and direct response. 0.92. What is the ratio of the Expenditure(as % of GDP) in Lao PDR in 2004 to that in 2005?
Make the answer very short. 1. What is the ratio of the Expenditure(as % of GDP) of Armenia in 2004 to that in 2006?
Offer a very short reply. 0.92. What is the ratio of the Expenditure(as % of GDP) in Denmark in 2004 to that in 2006?
Offer a terse response. 1.06. What is the ratio of the Expenditure(as % of GDP) in Lao PDR in 2004 to that in 2006?
Offer a terse response. 0.82. What is the ratio of the Expenditure(as % of GDP) of South Africa in 2004 to that in 2006?
Ensure brevity in your answer.  1. What is the ratio of the Expenditure(as % of GDP) of Armenia in 2004 to that in 2007?
Provide a succinct answer. 0.82. What is the ratio of the Expenditure(as % of GDP) of Denmark in 2004 to that in 2007?
Your response must be concise. 1.08. What is the ratio of the Expenditure(as % of GDP) in Lao PDR in 2004 to that in 2007?
Your answer should be compact. 0.78. What is the ratio of the Expenditure(as % of GDP) in South Africa in 2004 to that in 2007?
Your response must be concise. 1.02. What is the ratio of the Expenditure(as % of GDP) in Armenia in 2005 to that in 2006?
Give a very brief answer. 1. What is the ratio of the Expenditure(as % of GDP) in Denmark in 2005 to that in 2006?
Give a very brief answer. 1.05. What is the ratio of the Expenditure(as % of GDP) in Lao PDR in 2005 to that in 2006?
Your response must be concise. 0.82. What is the ratio of the Expenditure(as % of GDP) in South Africa in 2005 to that in 2006?
Ensure brevity in your answer.  1. What is the ratio of the Expenditure(as % of GDP) of Armenia in 2005 to that in 2007?
Offer a very short reply. 0.9. What is the ratio of the Expenditure(as % of GDP) of Denmark in 2005 to that in 2007?
Provide a short and direct response. 1.06. What is the ratio of the Expenditure(as % of GDP) in Lao PDR in 2005 to that in 2007?
Provide a succinct answer. 0.78. What is the ratio of the Expenditure(as % of GDP) in South Africa in 2005 to that in 2007?
Offer a very short reply. 1.02. What is the ratio of the Expenditure(as % of GDP) in Armenia in 2006 to that in 2007?
Keep it short and to the point. 0.9. What is the ratio of the Expenditure(as % of GDP) of Denmark in 2006 to that in 2007?
Keep it short and to the point. 1.01. What is the ratio of the Expenditure(as % of GDP) in Lao PDR in 2006 to that in 2007?
Provide a short and direct response. 0.96. What is the ratio of the Expenditure(as % of GDP) in South Africa in 2006 to that in 2007?
Offer a very short reply. 1.02. What is the difference between the highest and the second highest Expenditure(as % of GDP) in Armenia?
Ensure brevity in your answer.  0.25. What is the difference between the highest and the second highest Expenditure(as % of GDP) in Denmark?
Give a very brief answer. 0. What is the difference between the highest and the second highest Expenditure(as % of GDP) in Lao PDR?
Provide a short and direct response. 0.12. What is the difference between the highest and the second highest Expenditure(as % of GDP) in South Africa?
Provide a short and direct response. 0.28. What is the difference between the highest and the lowest Expenditure(as % of GDP) of Armenia?
Your answer should be compact. 0.88. What is the difference between the highest and the lowest Expenditure(as % of GDP) of Denmark?
Provide a succinct answer. 0.6. What is the difference between the highest and the lowest Expenditure(as % of GDP) of Lao PDR?
Keep it short and to the point. 1.57. What is the difference between the highest and the lowest Expenditure(as % of GDP) in South Africa?
Make the answer very short. 0.47. 